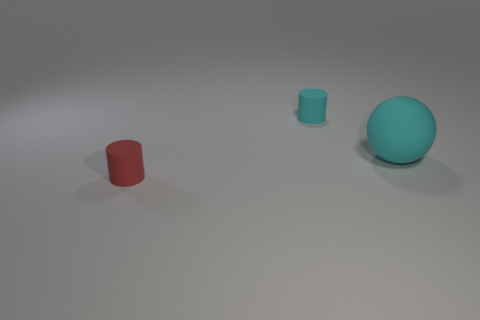What shape is the rubber object that is the same color as the rubber sphere?
Keep it short and to the point. Cylinder. How many other objects are there of the same shape as the large matte object?
Your response must be concise. 0. Do the big matte thing and the rubber cylinder that is behind the large cyan rubber ball have the same color?
Give a very brief answer. Yes. What number of purple matte things are there?
Your answer should be compact. 0. What number of objects are either red cylinders or small cylinders?
Your answer should be very brief. 2. Are there any big things to the left of the tiny cyan matte cylinder?
Provide a succinct answer. No. Is the number of tiny cyan cylinders behind the big rubber thing greater than the number of objects to the left of the red cylinder?
Your answer should be very brief. Yes. What number of cylinders are cyan objects or big things?
Provide a short and direct response. 1. Are there fewer cyan objects that are on the left side of the ball than objects that are in front of the small cyan object?
Offer a very short reply. Yes. How many objects are small cylinders that are in front of the big cyan sphere or gray rubber balls?
Your answer should be compact. 1. 